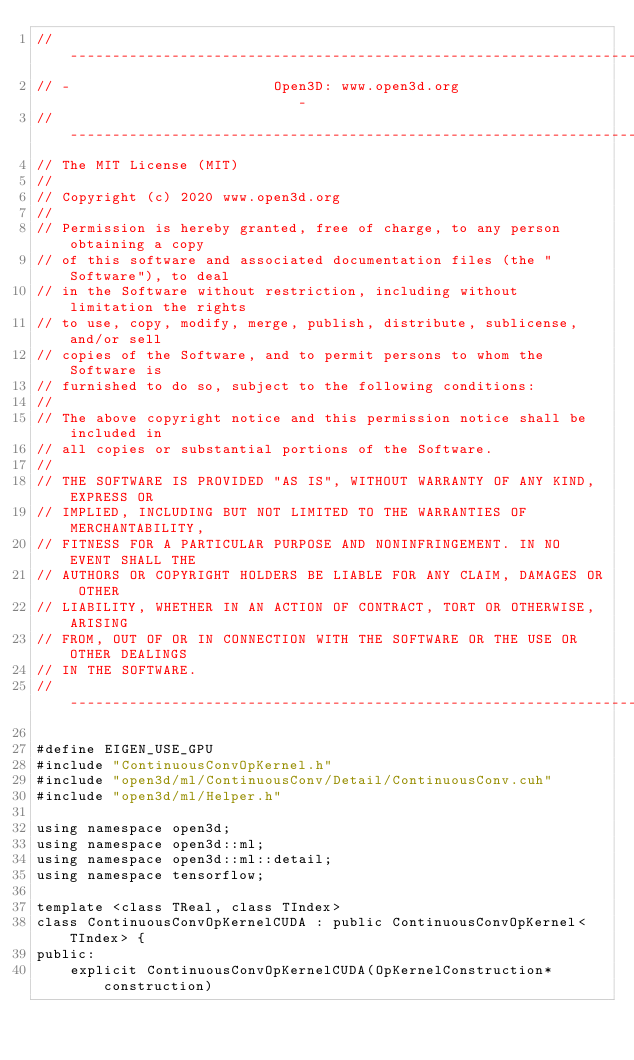<code> <loc_0><loc_0><loc_500><loc_500><_Cuda_>// ----------------------------------------------------------------------------
// -                        Open3D: www.open3d.org                            -
// ----------------------------------------------------------------------------
// The MIT License (MIT)
//
// Copyright (c) 2020 www.open3d.org
//
// Permission is hereby granted, free of charge, to any person obtaining a copy
// of this software and associated documentation files (the "Software"), to deal
// in the Software without restriction, including without limitation the rights
// to use, copy, modify, merge, publish, distribute, sublicense, and/or sell
// copies of the Software, and to permit persons to whom the Software is
// furnished to do so, subject to the following conditions:
//
// The above copyright notice and this permission notice shall be included in
// all copies or substantial portions of the Software.
//
// THE SOFTWARE IS PROVIDED "AS IS", WITHOUT WARRANTY OF ANY KIND, EXPRESS OR
// IMPLIED, INCLUDING BUT NOT LIMITED TO THE WARRANTIES OF MERCHANTABILITY,
// FITNESS FOR A PARTICULAR PURPOSE AND NONINFRINGEMENT. IN NO EVENT SHALL THE
// AUTHORS OR COPYRIGHT HOLDERS BE LIABLE FOR ANY CLAIM, DAMAGES OR OTHER
// LIABILITY, WHETHER IN AN ACTION OF CONTRACT, TORT OR OTHERWISE, ARISING
// FROM, OUT OF OR IN CONNECTION WITH THE SOFTWARE OR THE USE OR OTHER DEALINGS
// IN THE SOFTWARE.
// ----------------------------------------------------------------------------

#define EIGEN_USE_GPU
#include "ContinuousConvOpKernel.h"
#include "open3d/ml/ContinuousConv/Detail/ContinuousConv.cuh"
#include "open3d/ml/Helper.h"

using namespace open3d;
using namespace open3d::ml;
using namespace open3d::ml::detail;
using namespace tensorflow;

template <class TReal, class TIndex>
class ContinuousConvOpKernelCUDA : public ContinuousConvOpKernel<TIndex> {
public:
    explicit ContinuousConvOpKernelCUDA(OpKernelConstruction* construction)</code> 